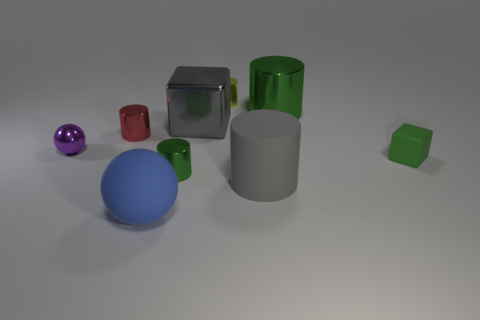Is the number of tiny yellow objects that are to the left of the tiny purple metal sphere the same as the number of small cubes that are in front of the large blue thing?
Ensure brevity in your answer.  Yes. How many small purple objects are the same shape as the large blue thing?
Your response must be concise. 1. Is there a tiny green object made of the same material as the small block?
Offer a terse response. No. The big matte object that is the same color as the large cube is what shape?
Keep it short and to the point. Cylinder. What number of small brown spheres are there?
Offer a very short reply. 0. What number of balls are either large green things or large cyan shiny objects?
Provide a succinct answer. 0. What color is the block that is the same size as the yellow metal cylinder?
Provide a short and direct response. Green. What number of small shiny objects are both in front of the small rubber block and behind the large green metal thing?
Make the answer very short. 0. What is the large green cylinder made of?
Your response must be concise. Metal. What number of objects are large gray matte things or small red things?
Offer a very short reply. 2. 